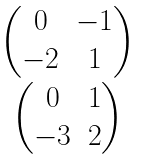<formula> <loc_0><loc_0><loc_500><loc_500>\begin{matrix} \begin{pmatrix} 0 & - 1 \\ - 2 & 1 \end{pmatrix} \\ \begin{pmatrix} 0 & 1 \\ - 3 & 2 \end{pmatrix} \end{matrix}</formula> 